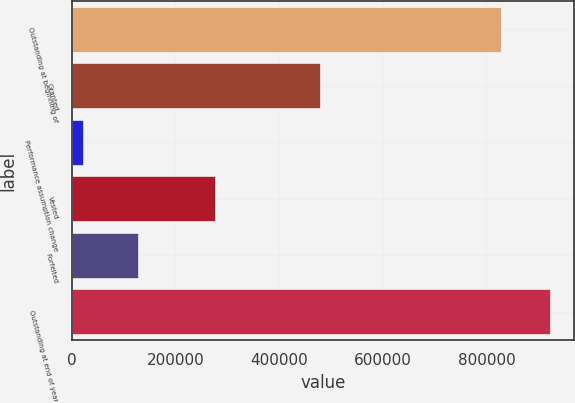Convert chart to OTSL. <chart><loc_0><loc_0><loc_500><loc_500><bar_chart><fcel>Outstanding at beginning of<fcel>Granted<fcel>Performance assumption change<fcel>Vested<fcel>Forfeited<fcel>Outstanding at end of year<nl><fcel>828228<fcel>478044<fcel>21305<fcel>277261<fcel>126952<fcel>923364<nl></chart> 